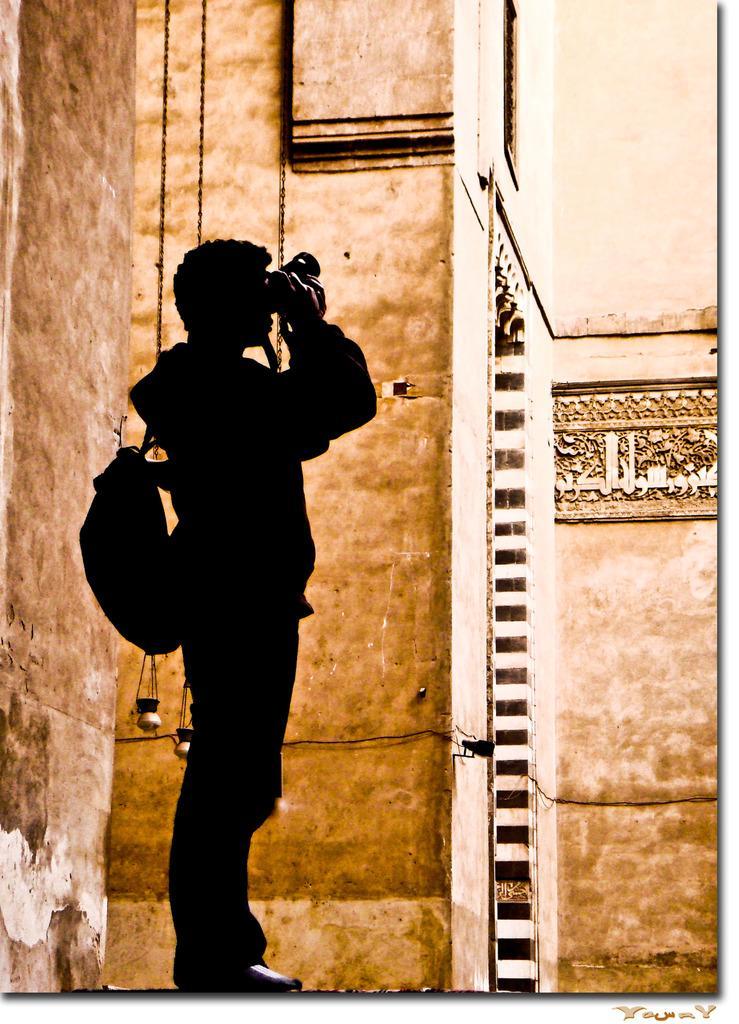How would you summarize this image in a sentence or two? In the picture we can see a man standing on the path, holding a camera and capturing something and he is wearing a bag and in the background we can see a wall with some paintings on it. 